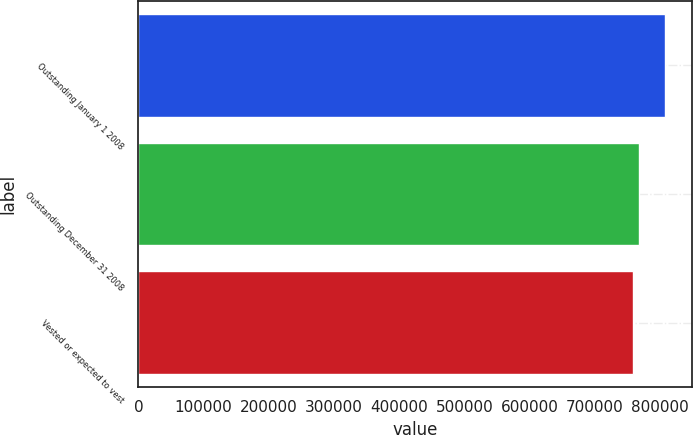<chart> <loc_0><loc_0><loc_500><loc_500><bar_chart><fcel>Outstanding January 1 2008<fcel>Outstanding December 31 2008<fcel>Vested or expected to vest<nl><fcel>808413<fcel>767940<fcel>759197<nl></chart> 